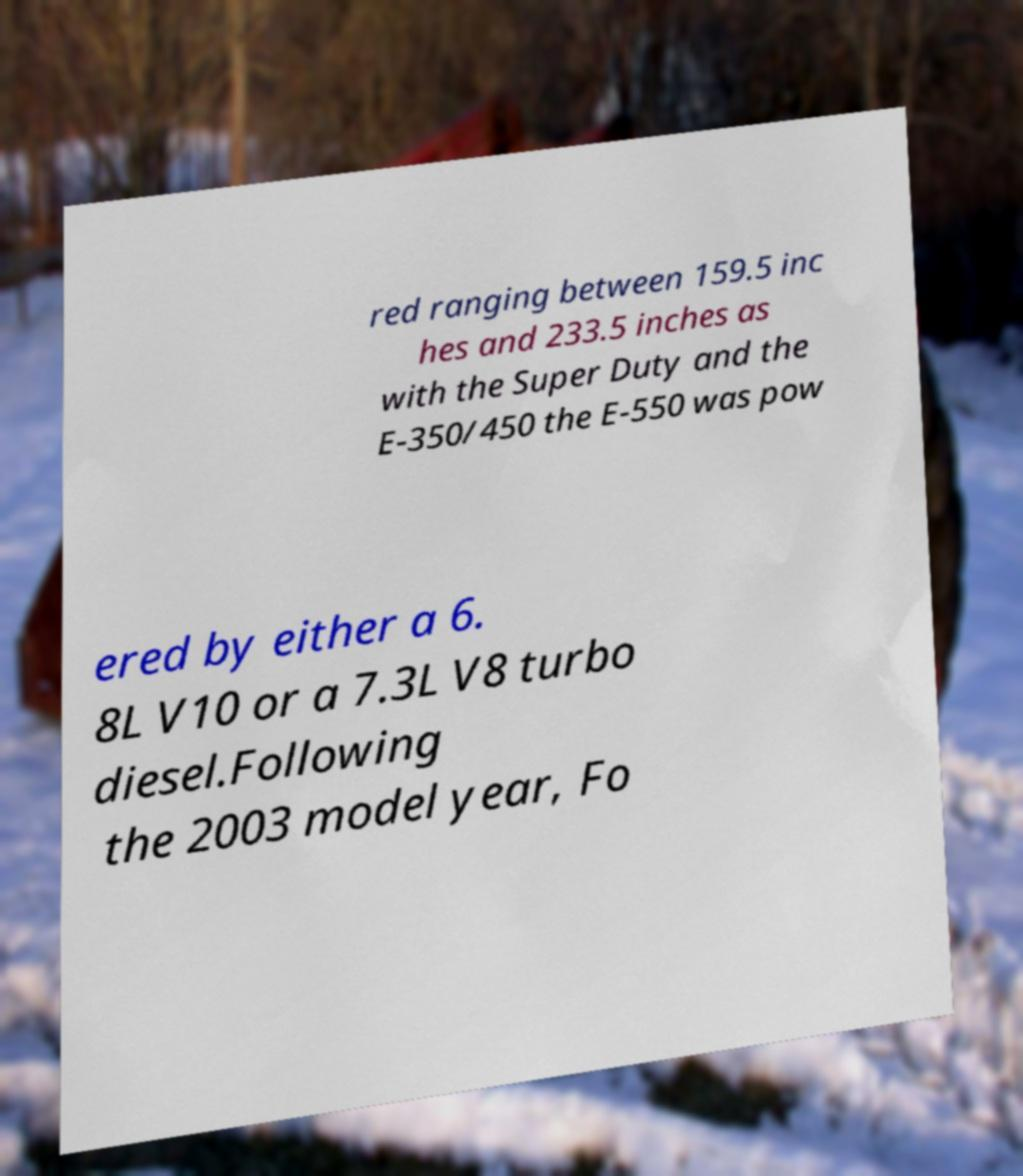Can you read and provide the text displayed in the image?This photo seems to have some interesting text. Can you extract and type it out for me? red ranging between 159.5 inc hes and 233.5 inches as with the Super Duty and the E-350/450 the E-550 was pow ered by either a 6. 8L V10 or a 7.3L V8 turbo diesel.Following the 2003 model year, Fo 